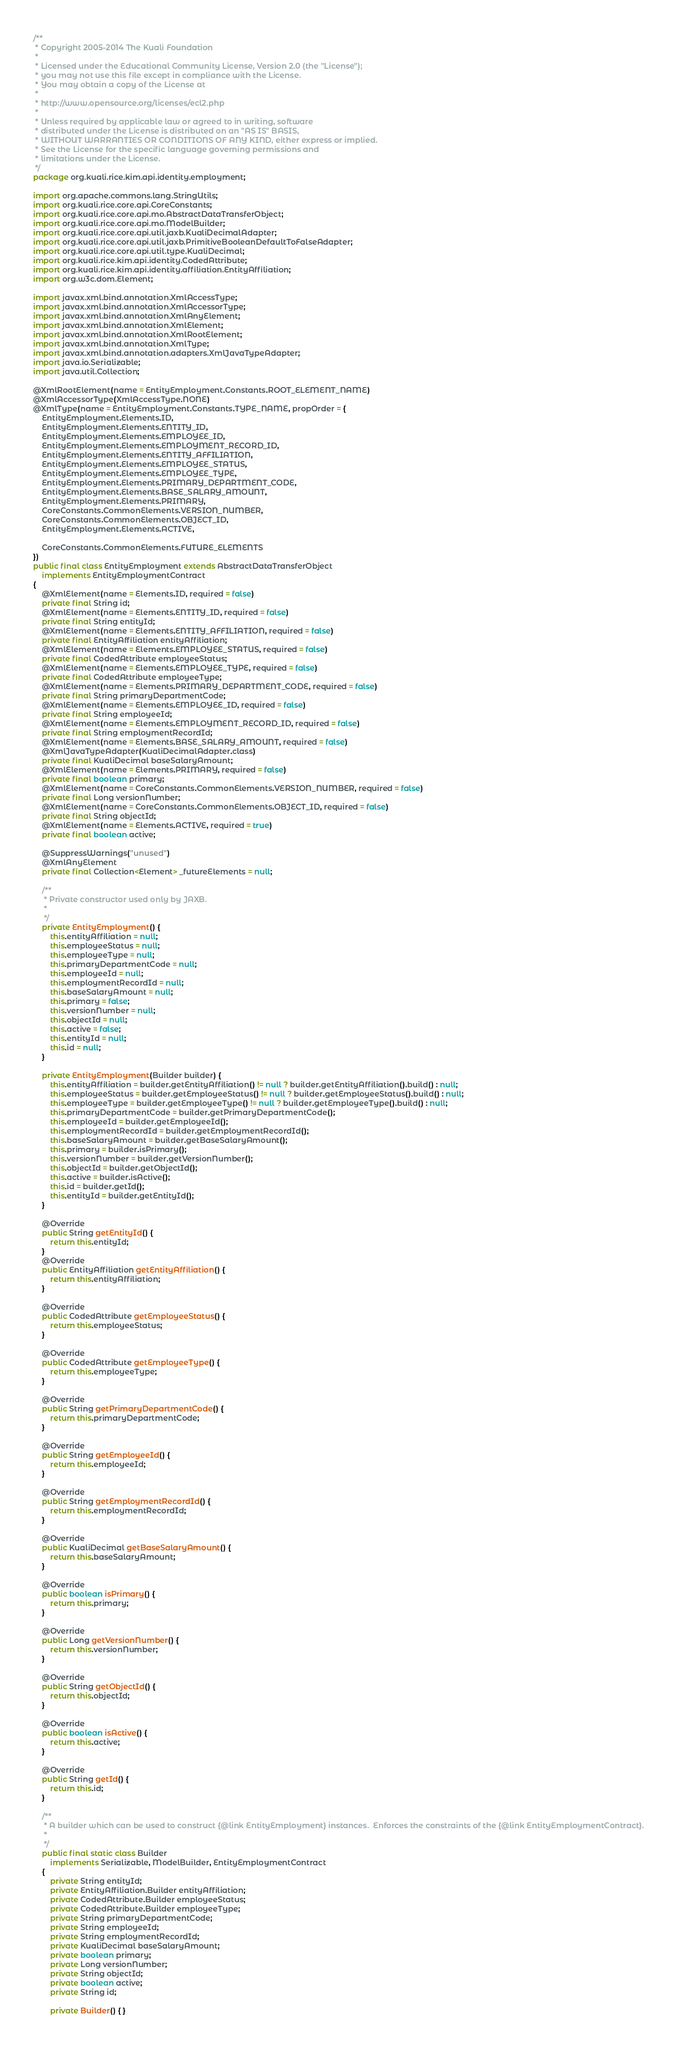<code> <loc_0><loc_0><loc_500><loc_500><_Java_>/**
 * Copyright 2005-2014 The Kuali Foundation
 *
 * Licensed under the Educational Community License, Version 2.0 (the "License");
 * you may not use this file except in compliance with the License.
 * You may obtain a copy of the License at
 *
 * http://www.opensource.org/licenses/ecl2.php
 *
 * Unless required by applicable law or agreed to in writing, software
 * distributed under the License is distributed on an "AS IS" BASIS,
 * WITHOUT WARRANTIES OR CONDITIONS OF ANY KIND, either express or implied.
 * See the License for the specific language governing permissions and
 * limitations under the License.
 */
package org.kuali.rice.kim.api.identity.employment;

import org.apache.commons.lang.StringUtils;
import org.kuali.rice.core.api.CoreConstants;
import org.kuali.rice.core.api.mo.AbstractDataTransferObject;
import org.kuali.rice.core.api.mo.ModelBuilder;
import org.kuali.rice.core.api.util.jaxb.KualiDecimalAdapter;
import org.kuali.rice.core.api.util.jaxb.PrimitiveBooleanDefaultToFalseAdapter;
import org.kuali.rice.core.api.util.type.KualiDecimal;
import org.kuali.rice.kim.api.identity.CodedAttribute;
import org.kuali.rice.kim.api.identity.affiliation.EntityAffiliation;
import org.w3c.dom.Element;

import javax.xml.bind.annotation.XmlAccessType;
import javax.xml.bind.annotation.XmlAccessorType;
import javax.xml.bind.annotation.XmlAnyElement;
import javax.xml.bind.annotation.XmlElement;
import javax.xml.bind.annotation.XmlRootElement;
import javax.xml.bind.annotation.XmlType;
import javax.xml.bind.annotation.adapters.XmlJavaTypeAdapter;
import java.io.Serializable;
import java.util.Collection;

@XmlRootElement(name = EntityEmployment.Constants.ROOT_ELEMENT_NAME)
@XmlAccessorType(XmlAccessType.NONE)
@XmlType(name = EntityEmployment.Constants.TYPE_NAME, propOrder = {
    EntityEmployment.Elements.ID,
    EntityEmployment.Elements.ENTITY_ID,
    EntityEmployment.Elements.EMPLOYEE_ID,
    EntityEmployment.Elements.EMPLOYMENT_RECORD_ID,
    EntityEmployment.Elements.ENTITY_AFFILIATION,
    EntityEmployment.Elements.EMPLOYEE_STATUS,
    EntityEmployment.Elements.EMPLOYEE_TYPE,
    EntityEmployment.Elements.PRIMARY_DEPARTMENT_CODE,
    EntityEmployment.Elements.BASE_SALARY_AMOUNT,
    EntityEmployment.Elements.PRIMARY,
    CoreConstants.CommonElements.VERSION_NUMBER,
    CoreConstants.CommonElements.OBJECT_ID,
    EntityEmployment.Elements.ACTIVE,

    CoreConstants.CommonElements.FUTURE_ELEMENTS
})
public final class EntityEmployment extends AbstractDataTransferObject
    implements EntityEmploymentContract
{
    @XmlElement(name = Elements.ID, required = false)
    private final String id;
    @XmlElement(name = Elements.ENTITY_ID, required = false)
    private final String entityId;
    @XmlElement(name = Elements.ENTITY_AFFILIATION, required = false)
    private final EntityAffiliation entityAffiliation;
    @XmlElement(name = Elements.EMPLOYEE_STATUS, required = false)
    private final CodedAttribute employeeStatus;
    @XmlElement(name = Elements.EMPLOYEE_TYPE, required = false)
    private final CodedAttribute employeeType;
    @XmlElement(name = Elements.PRIMARY_DEPARTMENT_CODE, required = false)
    private final String primaryDepartmentCode;
    @XmlElement(name = Elements.EMPLOYEE_ID, required = false)
    private final String employeeId;
    @XmlElement(name = Elements.EMPLOYMENT_RECORD_ID, required = false)
    private final String employmentRecordId;
    @XmlElement(name = Elements.BASE_SALARY_AMOUNT, required = false)
    @XmlJavaTypeAdapter(KualiDecimalAdapter.class)
    private final KualiDecimal baseSalaryAmount;
    @XmlElement(name = Elements.PRIMARY, required = false)
    private final boolean primary;
    @XmlElement(name = CoreConstants.CommonElements.VERSION_NUMBER, required = false)
    private final Long versionNumber;
    @XmlElement(name = CoreConstants.CommonElements.OBJECT_ID, required = false)
    private final String objectId;
    @XmlElement(name = Elements.ACTIVE, required = true)
    private final boolean active;

    @SuppressWarnings("unused")
    @XmlAnyElement
    private final Collection<Element> _futureElements = null;

    /**
     * Private constructor used only by JAXB.
     * 
     */
    private EntityEmployment() {
        this.entityAffiliation = null;
        this.employeeStatus = null;
        this.employeeType = null;
        this.primaryDepartmentCode = null;
        this.employeeId = null;
        this.employmentRecordId = null;
        this.baseSalaryAmount = null;
        this.primary = false;
        this.versionNumber = null;
        this.objectId = null;
        this.active = false;
        this.entityId = null;
        this.id = null;
    }

    private EntityEmployment(Builder builder) {
        this.entityAffiliation = builder.getEntityAffiliation() != null ? builder.getEntityAffiliation().build() : null;
        this.employeeStatus = builder.getEmployeeStatus() != null ? builder.getEmployeeStatus().build() : null;
        this.employeeType = builder.getEmployeeType() != null ? builder.getEmployeeType().build() : null;
        this.primaryDepartmentCode = builder.getPrimaryDepartmentCode();
        this.employeeId = builder.getEmployeeId();
        this.employmentRecordId = builder.getEmploymentRecordId();
        this.baseSalaryAmount = builder.getBaseSalaryAmount();
        this.primary = builder.isPrimary();
        this.versionNumber = builder.getVersionNumber();
        this.objectId = builder.getObjectId();
        this.active = builder.isActive();
        this.id = builder.getId();
        this.entityId = builder.getEntityId();
    }

    @Override
    public String getEntityId() {
        return this.entityId;
    }
    @Override
    public EntityAffiliation getEntityAffiliation() {
        return this.entityAffiliation;
    }

    @Override
    public CodedAttribute getEmployeeStatus() {
        return this.employeeStatus;
    }

    @Override
    public CodedAttribute getEmployeeType() {
        return this.employeeType;
    }

    @Override
    public String getPrimaryDepartmentCode() {
        return this.primaryDepartmentCode;
    }

    @Override
    public String getEmployeeId() {
        return this.employeeId;
    }

    @Override
    public String getEmploymentRecordId() {
        return this.employmentRecordId;
    }

    @Override
    public KualiDecimal getBaseSalaryAmount() {
        return this.baseSalaryAmount;
    }

    @Override
    public boolean isPrimary() {
        return this.primary;
    }

    @Override
    public Long getVersionNumber() {
        return this.versionNumber;
    }

    @Override
    public String getObjectId() {
        return this.objectId;
    }

    @Override
    public boolean isActive() {
        return this.active;
    }

    @Override
    public String getId() {
        return this.id;
    }

    /**
     * A builder which can be used to construct {@link EntityEmployment} instances.  Enforces the constraints of the {@link EntityEmploymentContract}.
     * 
     */
    public final static class Builder
        implements Serializable, ModelBuilder, EntityEmploymentContract
    {
        private String entityId;
        private EntityAffiliation.Builder entityAffiliation;
        private CodedAttribute.Builder employeeStatus;
        private CodedAttribute.Builder employeeType;
        private String primaryDepartmentCode;
        private String employeeId;
        private String employmentRecordId;
        private KualiDecimal baseSalaryAmount;
        private boolean primary;
        private Long versionNumber;
        private String objectId;
        private boolean active;
        private String id;

        private Builder() { }
</code> 